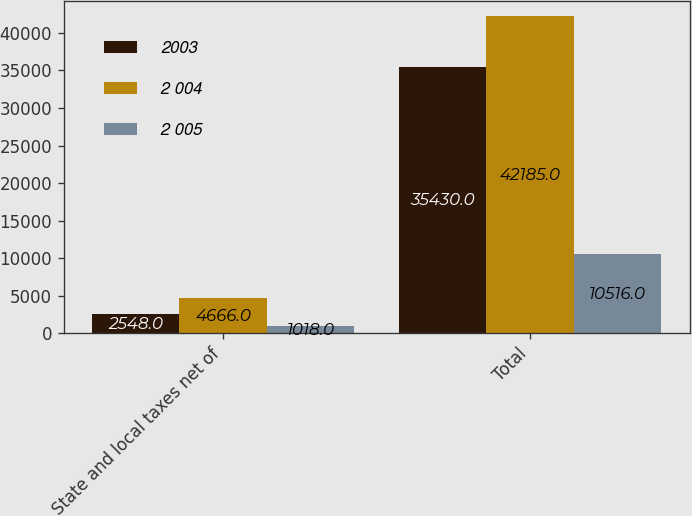Convert chart. <chart><loc_0><loc_0><loc_500><loc_500><stacked_bar_chart><ecel><fcel>State and local taxes net of<fcel>Total<nl><fcel>2003<fcel>2548<fcel>35430<nl><fcel>2 004<fcel>4666<fcel>42185<nl><fcel>2 005<fcel>1018<fcel>10516<nl></chart> 